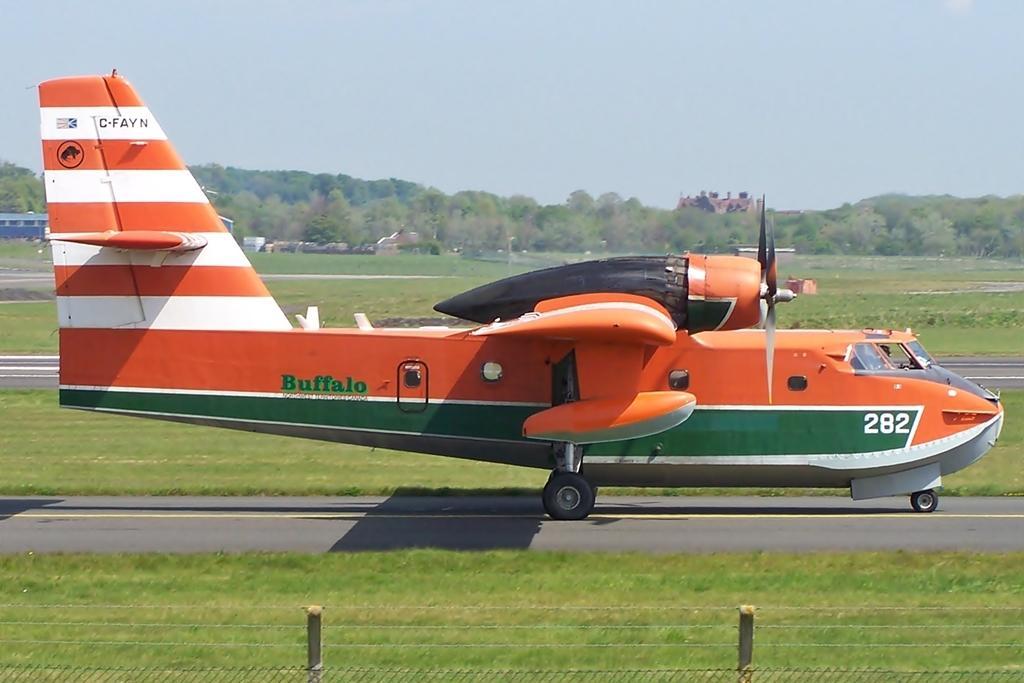In one or two sentences, can you explain what this image depicts? In this image there is an airplane on the road. People are in the air plane. Left side there are buildings. Background there are trees. Top of the image there is sky. 